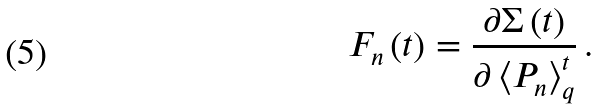Convert formula to latex. <formula><loc_0><loc_0><loc_500><loc_500>F _ { n } \left ( t \right ) = \frac { \partial \Sigma \left ( t \right ) } { \partial \left \langle P _ { n } \right \rangle _ { q } ^ { t } } \, .</formula> 